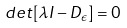<formula> <loc_0><loc_0><loc_500><loc_500>d e t [ { \lambda } I - { D } _ { \epsilon } ] = 0</formula> 